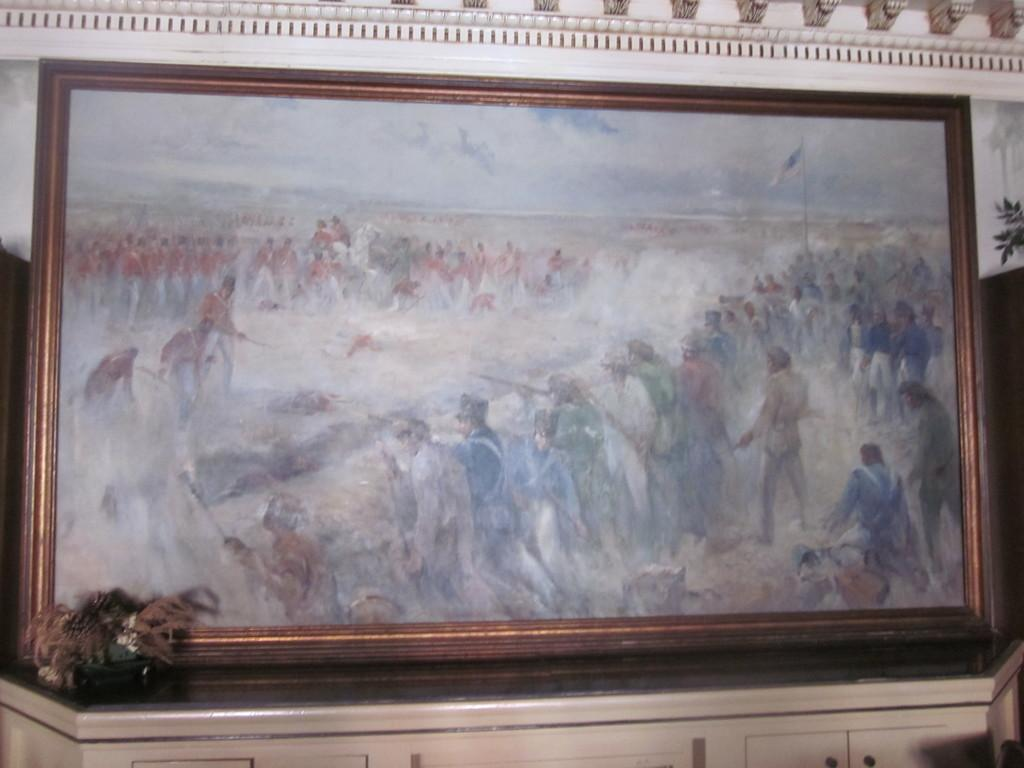What is the main object in the image? There is a frame in the image. What else can be seen in the image besides the frame? There is a pot plant in the image. Where are the frame and pot plant located? The frame and pot plant are on a platform. What other piece of furniture is visible in the image? There is a desk visible at the bottom portion of the image. What type of steel is used to construct the ocean in the image? There is no ocean present in the image, and therefore no steel construction involved. 